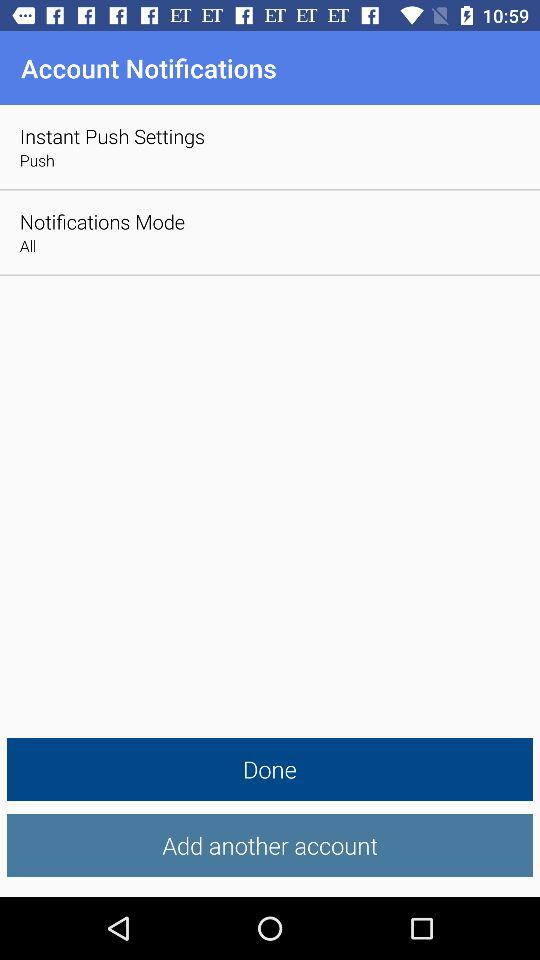Which option is selected in "Instant Push Settings"? The selected option in "Instant Push Settings" is "Push". 